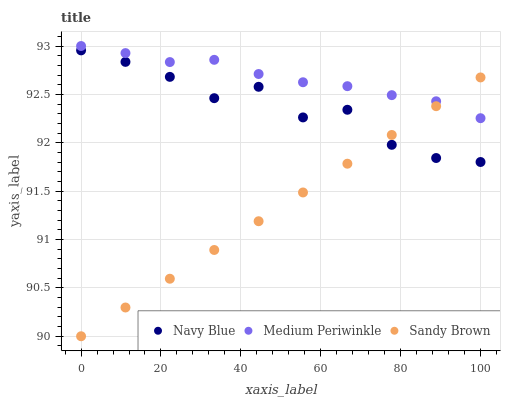Does Sandy Brown have the minimum area under the curve?
Answer yes or no. Yes. Does Medium Periwinkle have the maximum area under the curve?
Answer yes or no. Yes. Does Medium Periwinkle have the minimum area under the curve?
Answer yes or no. No. Does Sandy Brown have the maximum area under the curve?
Answer yes or no. No. Is Sandy Brown the smoothest?
Answer yes or no. Yes. Is Navy Blue the roughest?
Answer yes or no. Yes. Is Medium Periwinkle the smoothest?
Answer yes or no. No. Is Medium Periwinkle the roughest?
Answer yes or no. No. Does Sandy Brown have the lowest value?
Answer yes or no. Yes. Does Medium Periwinkle have the lowest value?
Answer yes or no. No. Does Medium Periwinkle have the highest value?
Answer yes or no. Yes. Does Sandy Brown have the highest value?
Answer yes or no. No. Is Navy Blue less than Medium Periwinkle?
Answer yes or no. Yes. Is Medium Periwinkle greater than Navy Blue?
Answer yes or no. Yes. Does Navy Blue intersect Sandy Brown?
Answer yes or no. Yes. Is Navy Blue less than Sandy Brown?
Answer yes or no. No. Is Navy Blue greater than Sandy Brown?
Answer yes or no. No. Does Navy Blue intersect Medium Periwinkle?
Answer yes or no. No. 